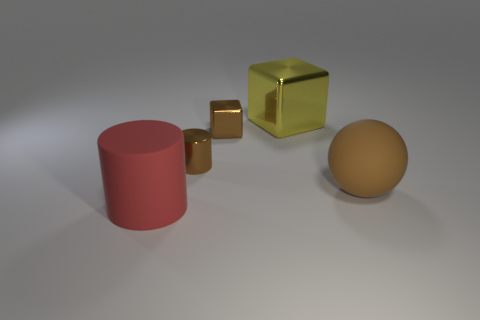How many spheres are tiny purple things or matte objects? In the image, there are no tiny purple things. However, focusing on matte objects, it appears there is one matte sphere. Therefore, there is only one item that fits the criteria of being a matte object among the spheres. 